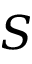Convert formula to latex. <formula><loc_0><loc_0><loc_500><loc_500>S</formula> 